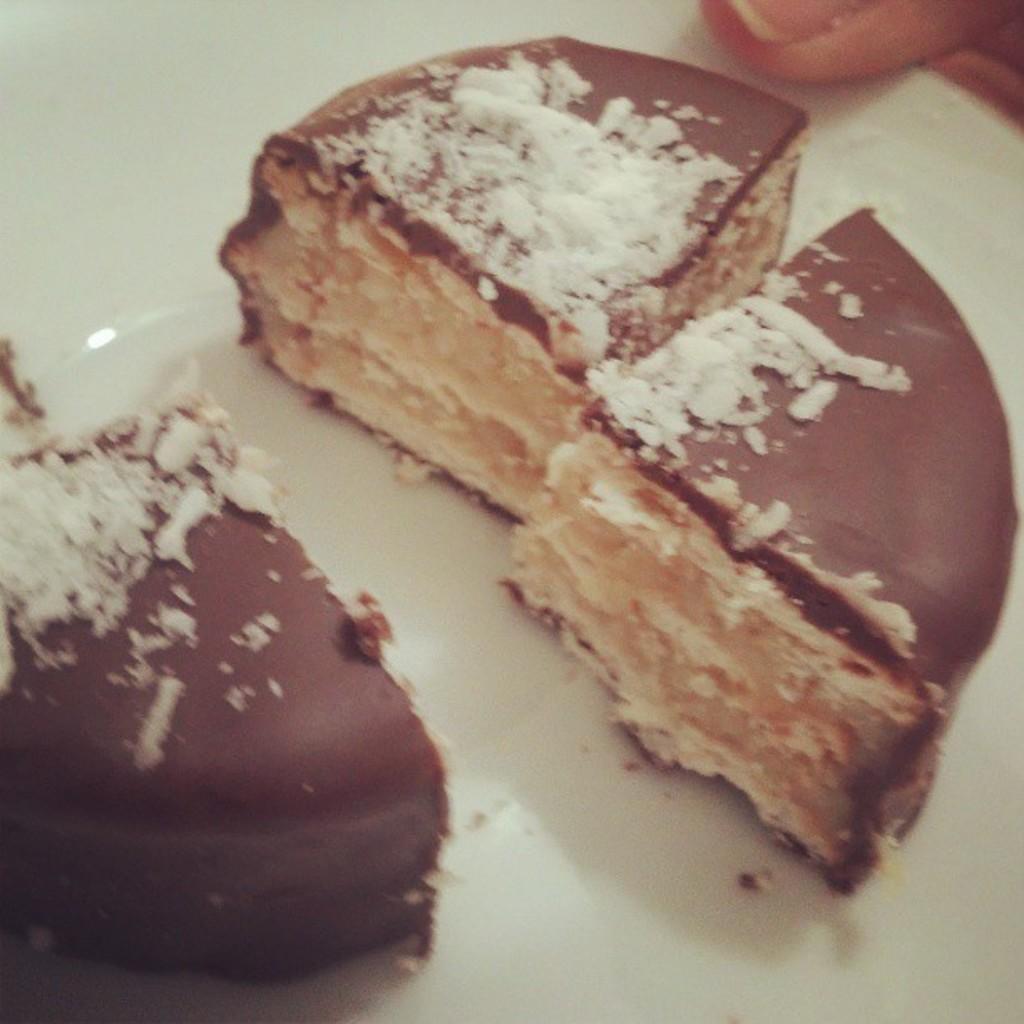Can you describe this image briefly? In this image we can see some pieces of cake in a plate. At the top of the image we can see the finger of a person. 